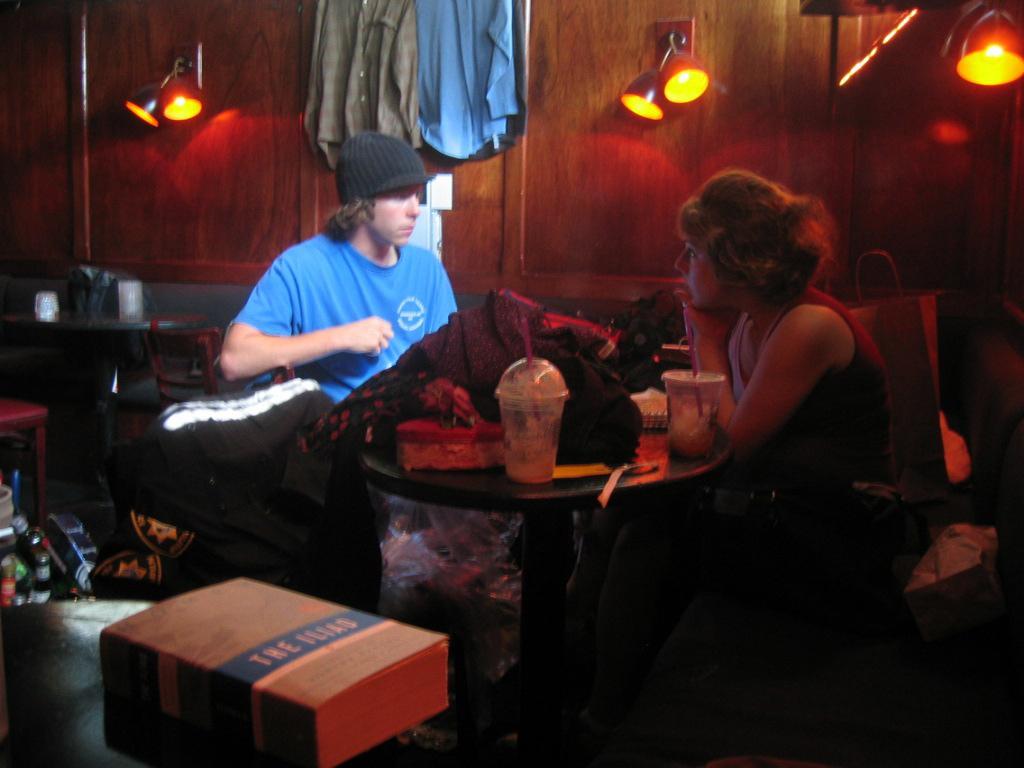Describe this image in one or two sentences. A man is sitting he wore a blue color t-shirt, in the right side a beautiful girl is sitting. She wore a t-shirt, there are food items on this table. 